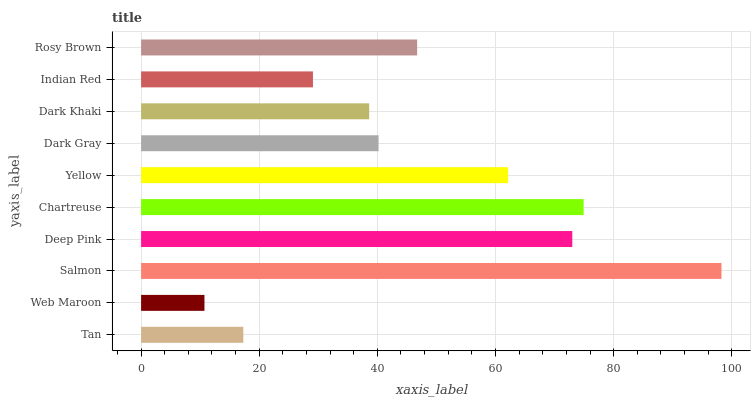Is Web Maroon the minimum?
Answer yes or no. Yes. Is Salmon the maximum?
Answer yes or no. Yes. Is Salmon the minimum?
Answer yes or no. No. Is Web Maroon the maximum?
Answer yes or no. No. Is Salmon greater than Web Maroon?
Answer yes or no. Yes. Is Web Maroon less than Salmon?
Answer yes or no. Yes. Is Web Maroon greater than Salmon?
Answer yes or no. No. Is Salmon less than Web Maroon?
Answer yes or no. No. Is Rosy Brown the high median?
Answer yes or no. Yes. Is Dark Gray the low median?
Answer yes or no. Yes. Is Deep Pink the high median?
Answer yes or no. No. Is Dark Khaki the low median?
Answer yes or no. No. 